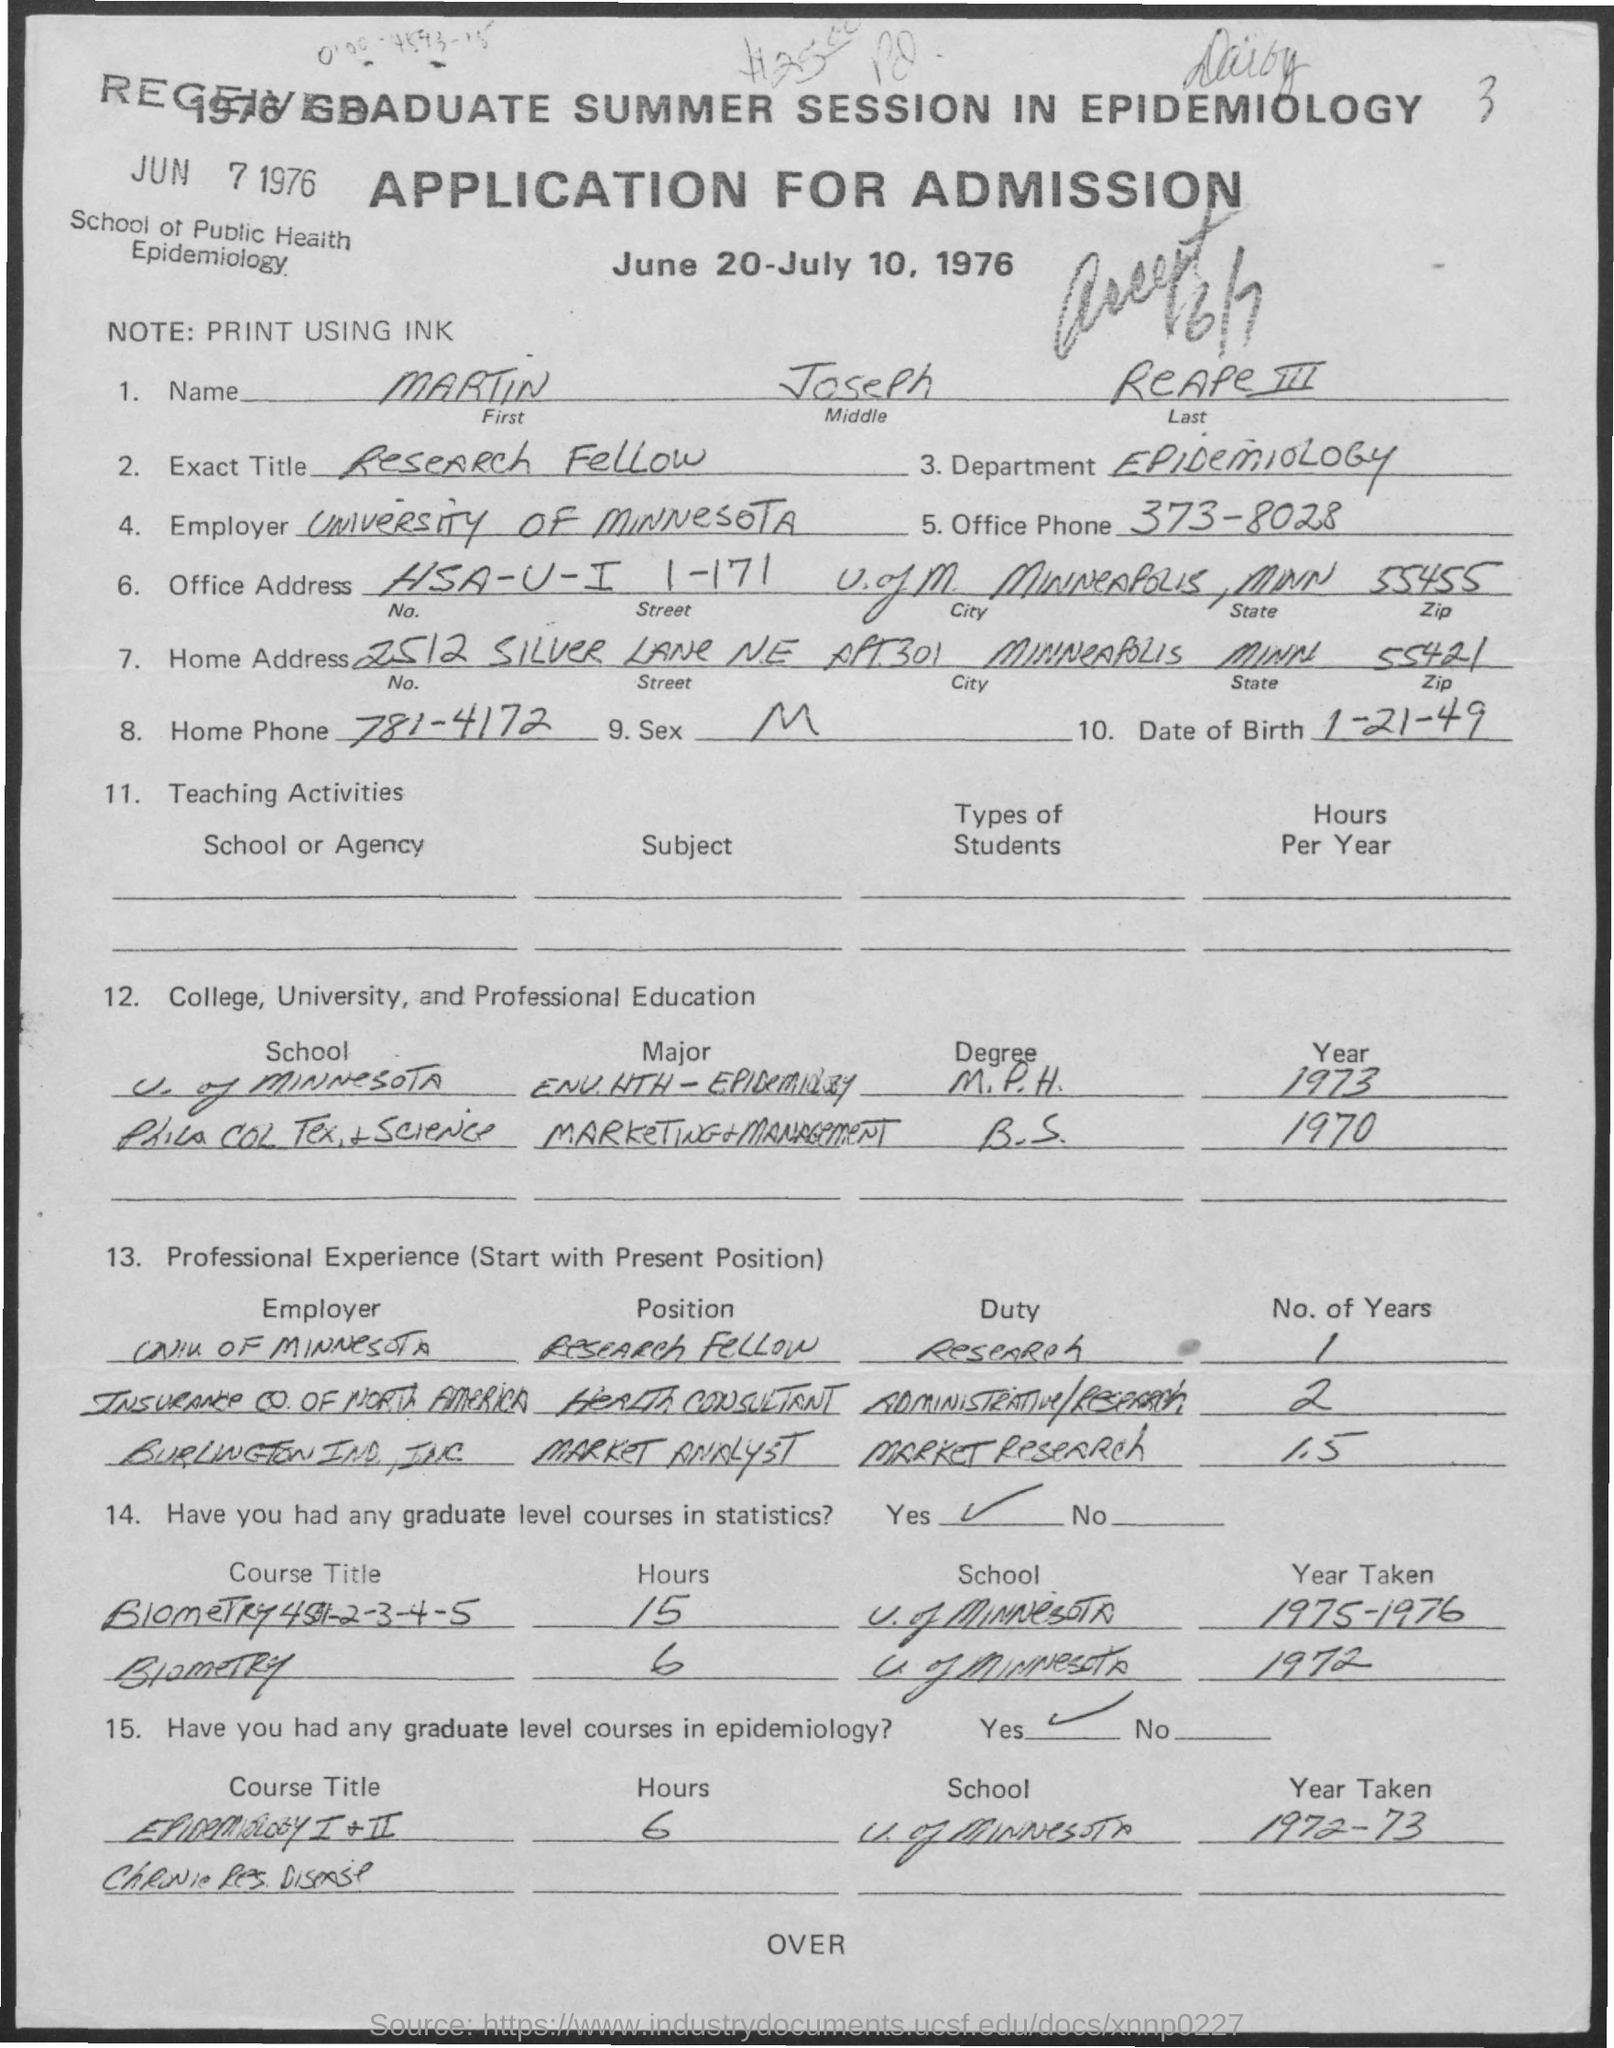What is written in the Exact Title Field ?
Your answer should be very brief. Research Fellow. What is the Department Name  ?
Offer a terse response. Epidemiology. What is the Date of birth of Martin ?
Provide a short and direct response. 1-21-49. What is the Office Phone Number ?
Your response must be concise. 373-8028. What is the Home Phone Number ?
Ensure brevity in your answer.  781-4172. What is written in the Note Field ?
Offer a terse response. Print Using Ink. What is written in the Sex Field ?
Offer a very short reply. M. 